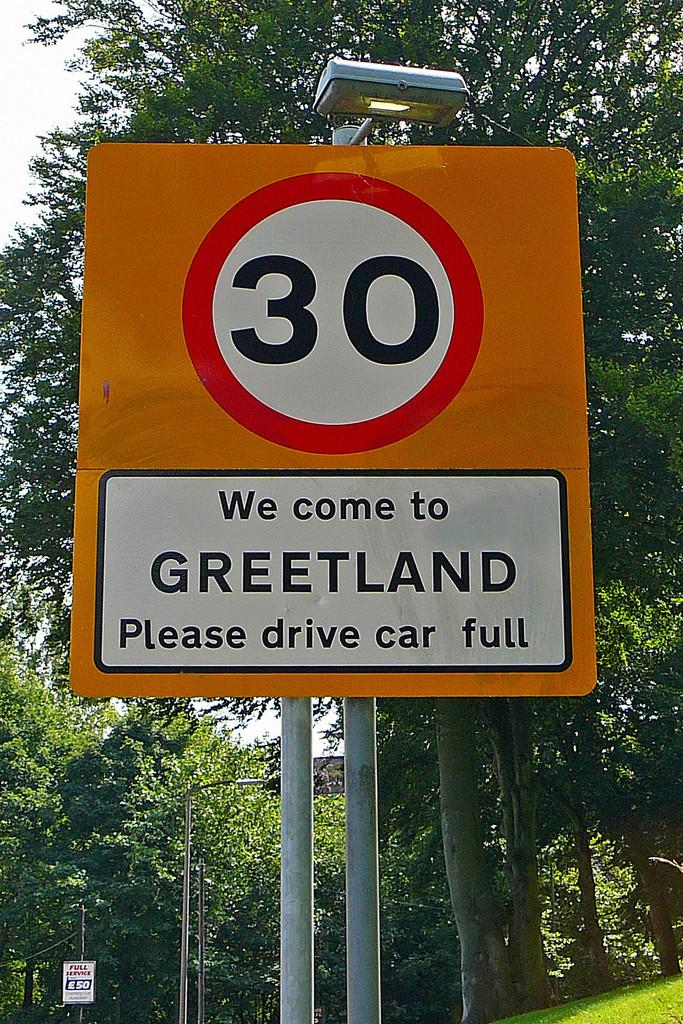<image>
Present a compact description of the photo's key features. An orange sign says We come to Greetland Please drive car full and trees are behind it. 